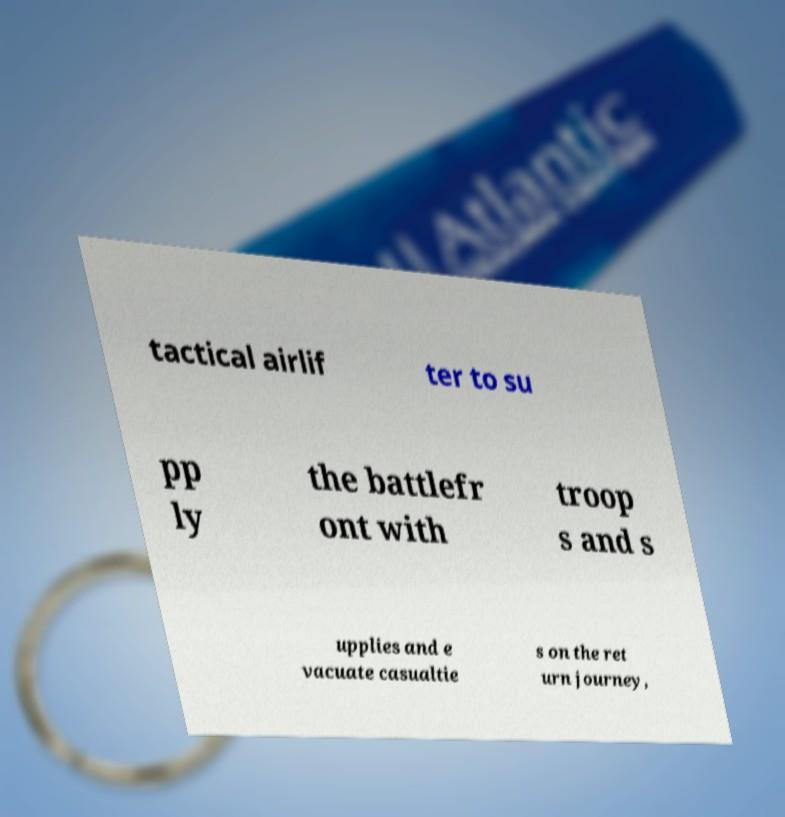Please identify and transcribe the text found in this image. tactical airlif ter to su pp ly the battlefr ont with troop s and s upplies and e vacuate casualtie s on the ret urn journey, 